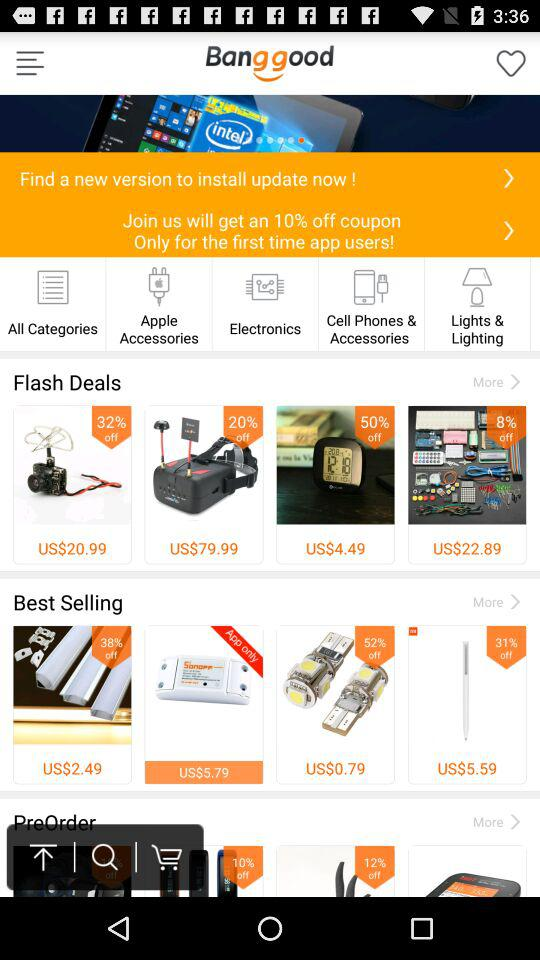What is the name of the application? The name of the application is "Bang good". 